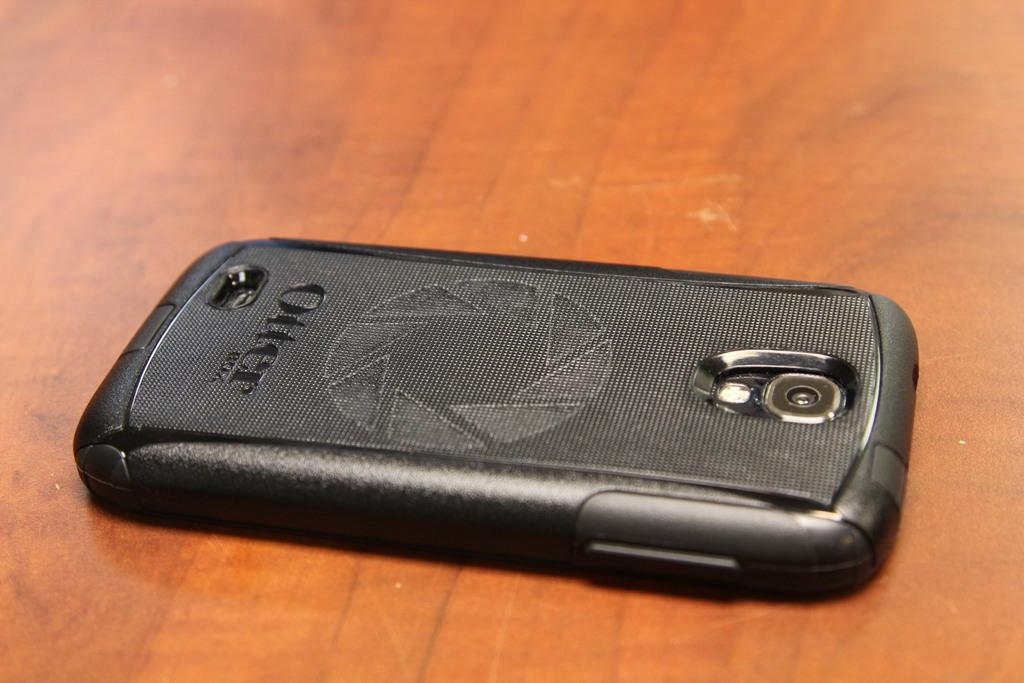<image>
Write a terse but informative summary of the picture. a cellphone face down on a table with the word otter on it 